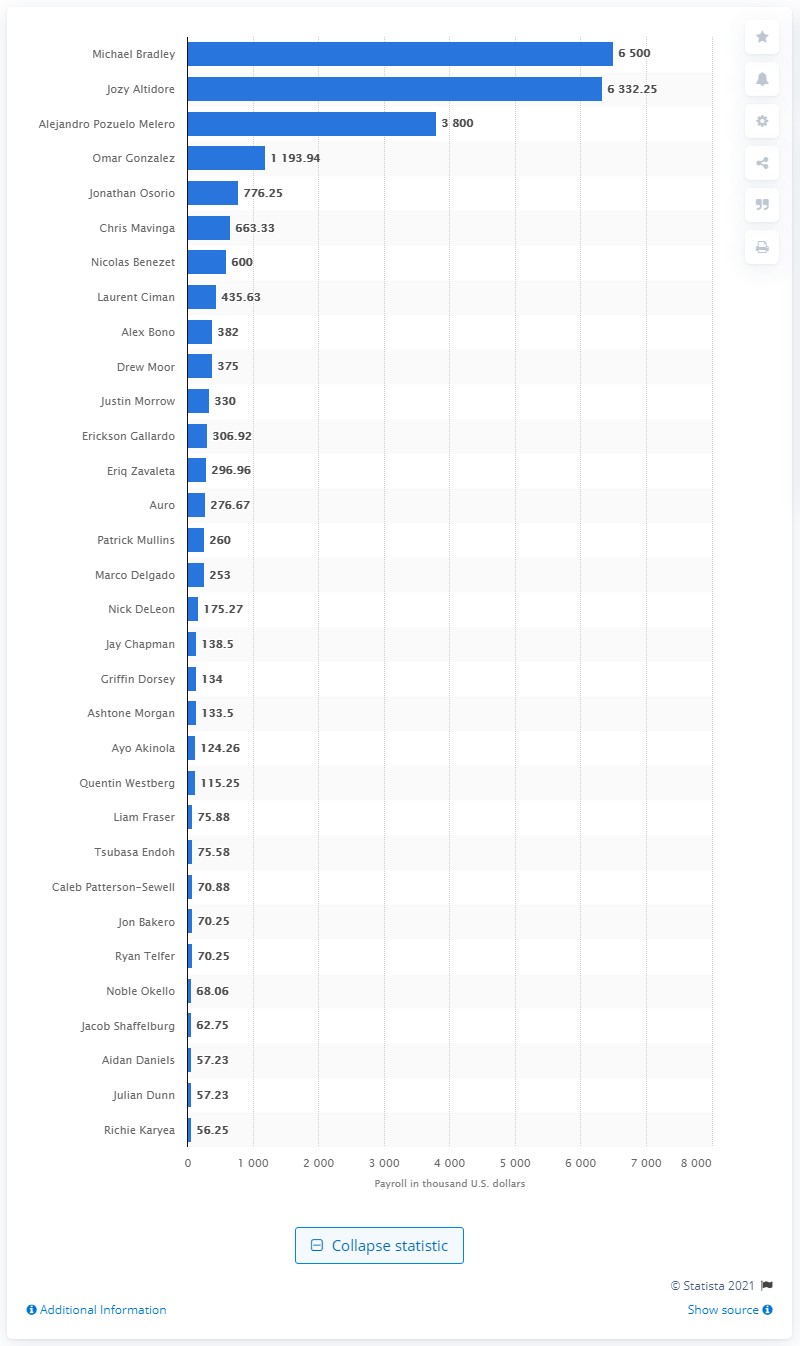List a handful of essential elements in this visual. In 2019, Michael Bradley received a salary of 6.5 million U.S. dollars. 